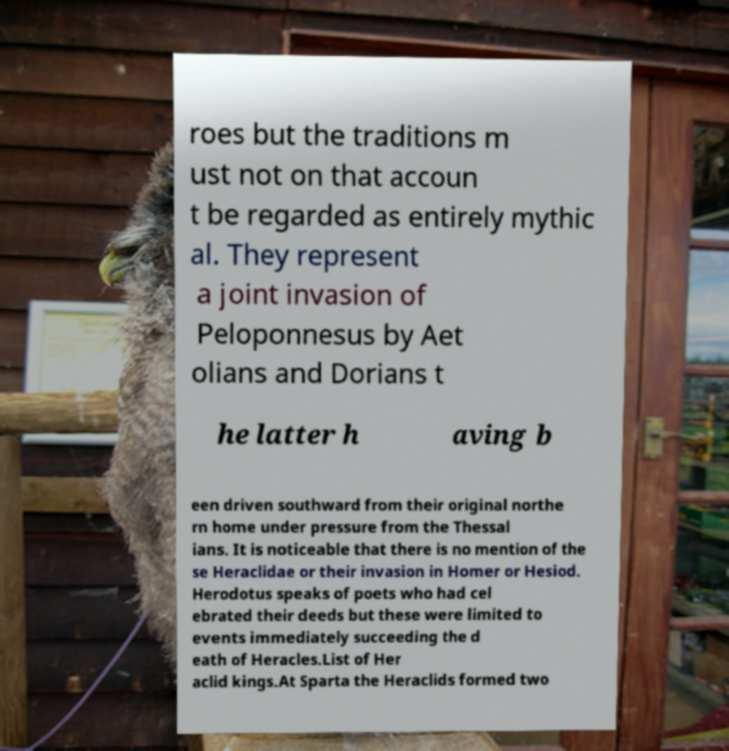There's text embedded in this image that I need extracted. Can you transcribe it verbatim? roes but the traditions m ust not on that accoun t be regarded as entirely mythic al. They represent a joint invasion of Peloponnesus by Aet olians and Dorians t he latter h aving b een driven southward from their original northe rn home under pressure from the Thessal ians. It is noticeable that there is no mention of the se Heraclidae or their invasion in Homer or Hesiod. Herodotus speaks of poets who had cel ebrated their deeds but these were limited to events immediately succeeding the d eath of Heracles.List of Her aclid kings.At Sparta the Heraclids formed two 